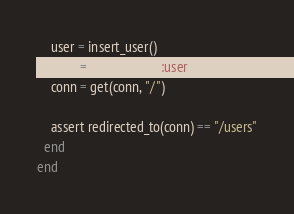Convert code to text. <code><loc_0><loc_0><loc_500><loc_500><_Elixir_>    user = insert_user()
    conn = assign(conn, :user, user)
    conn = get(conn, "/")

    assert redirected_to(conn) == "/users"
  end
end
</code> 